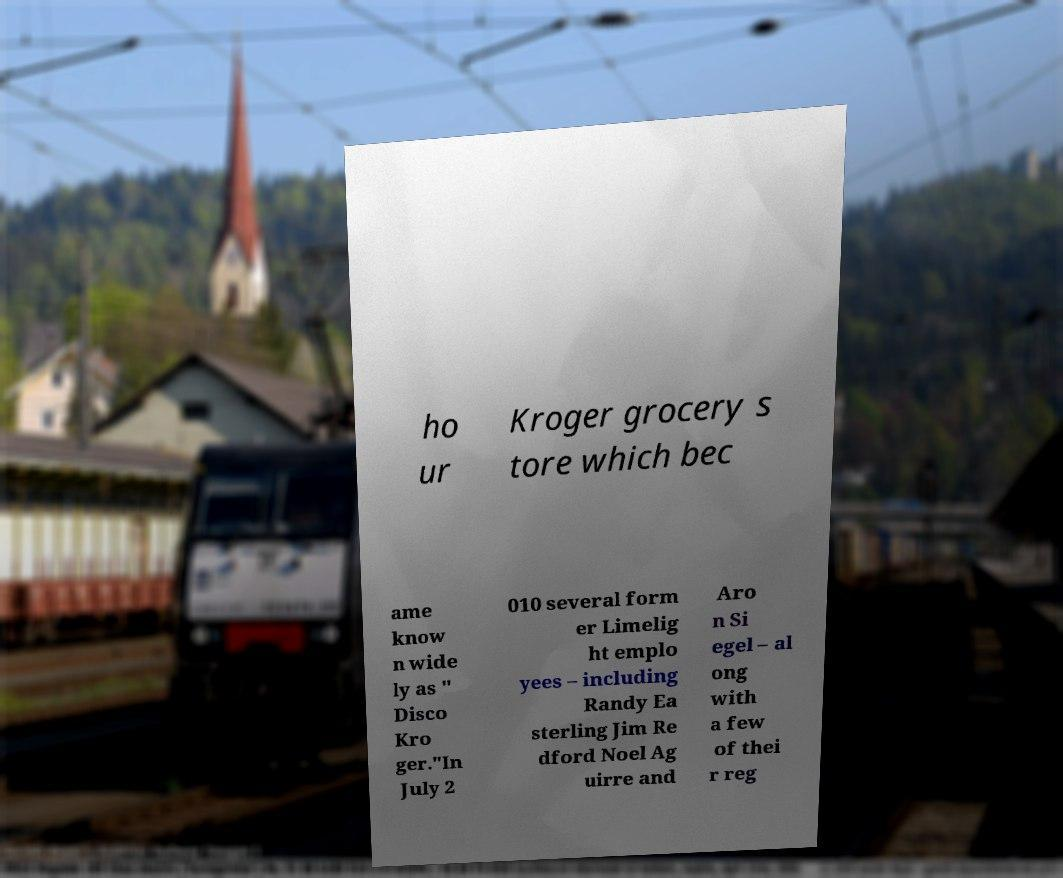Could you extract and type out the text from this image? ho ur Kroger grocery s tore which bec ame know n wide ly as " Disco Kro ger."In July 2 010 several form er Limelig ht emplo yees – including Randy Ea sterling Jim Re dford Noel Ag uirre and Aro n Si egel – al ong with a few of thei r reg 